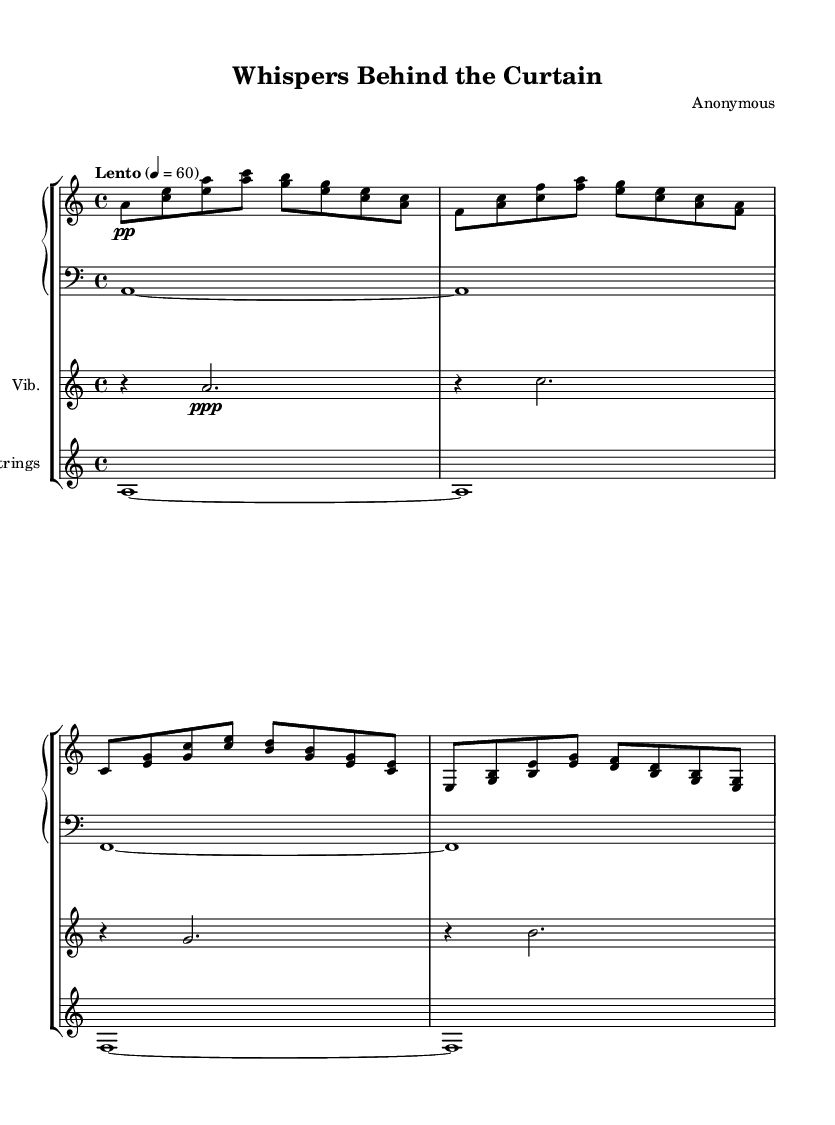What is the key signature of this music? The key signature indicated in the music is A minor, which has no sharps or flats.
Answer: A minor What is the time signature of the piece? The time signature is shown in the beginning of the piece as 4/4, indicating four beats per measure.
Answer: 4/4 What is the tempo marking for this composition? The tempo marking is indicated as "Lento," which suggests a slow speed, specifically a pace of 60 beats per minute.
Answer: Lento How many measures are there in the upper piano part? Counting the measures in the upper piano part reveals there are eight measures present in total.
Answer: Eight measures What kind of instruments are used in this piece? The instruments listed include Piano, Vibraphone, and Strings, indicating a blend of textures and sound qualities.
Answer: Piano, Vibraphone, Strings What dynamics indicate the softness of the piece? The dynamics show markings of "pp" and "ppp," which indicate very soft playing, enhancing the ambient atmosphere typical of experimental compositions.
Answer: pp, ppp How does the structure of the music enhance its experimental nature? The music employs sustained notes and minimalistic patterns, characteristic of ambient compositions, creating an immersive and atmospheric backdrop that mirrors backstage preparations.
Answer: Sustained notes, minimalistic patterns 